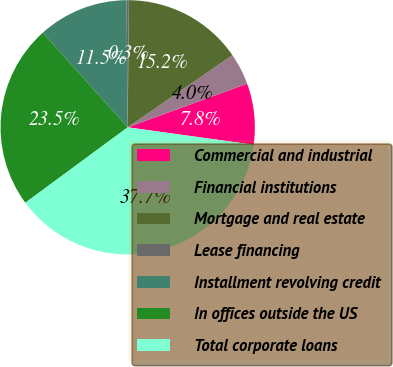Convert chart. <chart><loc_0><loc_0><loc_500><loc_500><pie_chart><fcel>Commercial and industrial<fcel>Financial institutions<fcel>Mortgage and real estate<fcel>Lease financing<fcel>Installment revolving credit<fcel>In offices outside the US<fcel>Total corporate loans<nl><fcel>7.77%<fcel>4.03%<fcel>15.25%<fcel>0.29%<fcel>11.51%<fcel>23.45%<fcel>37.7%<nl></chart> 